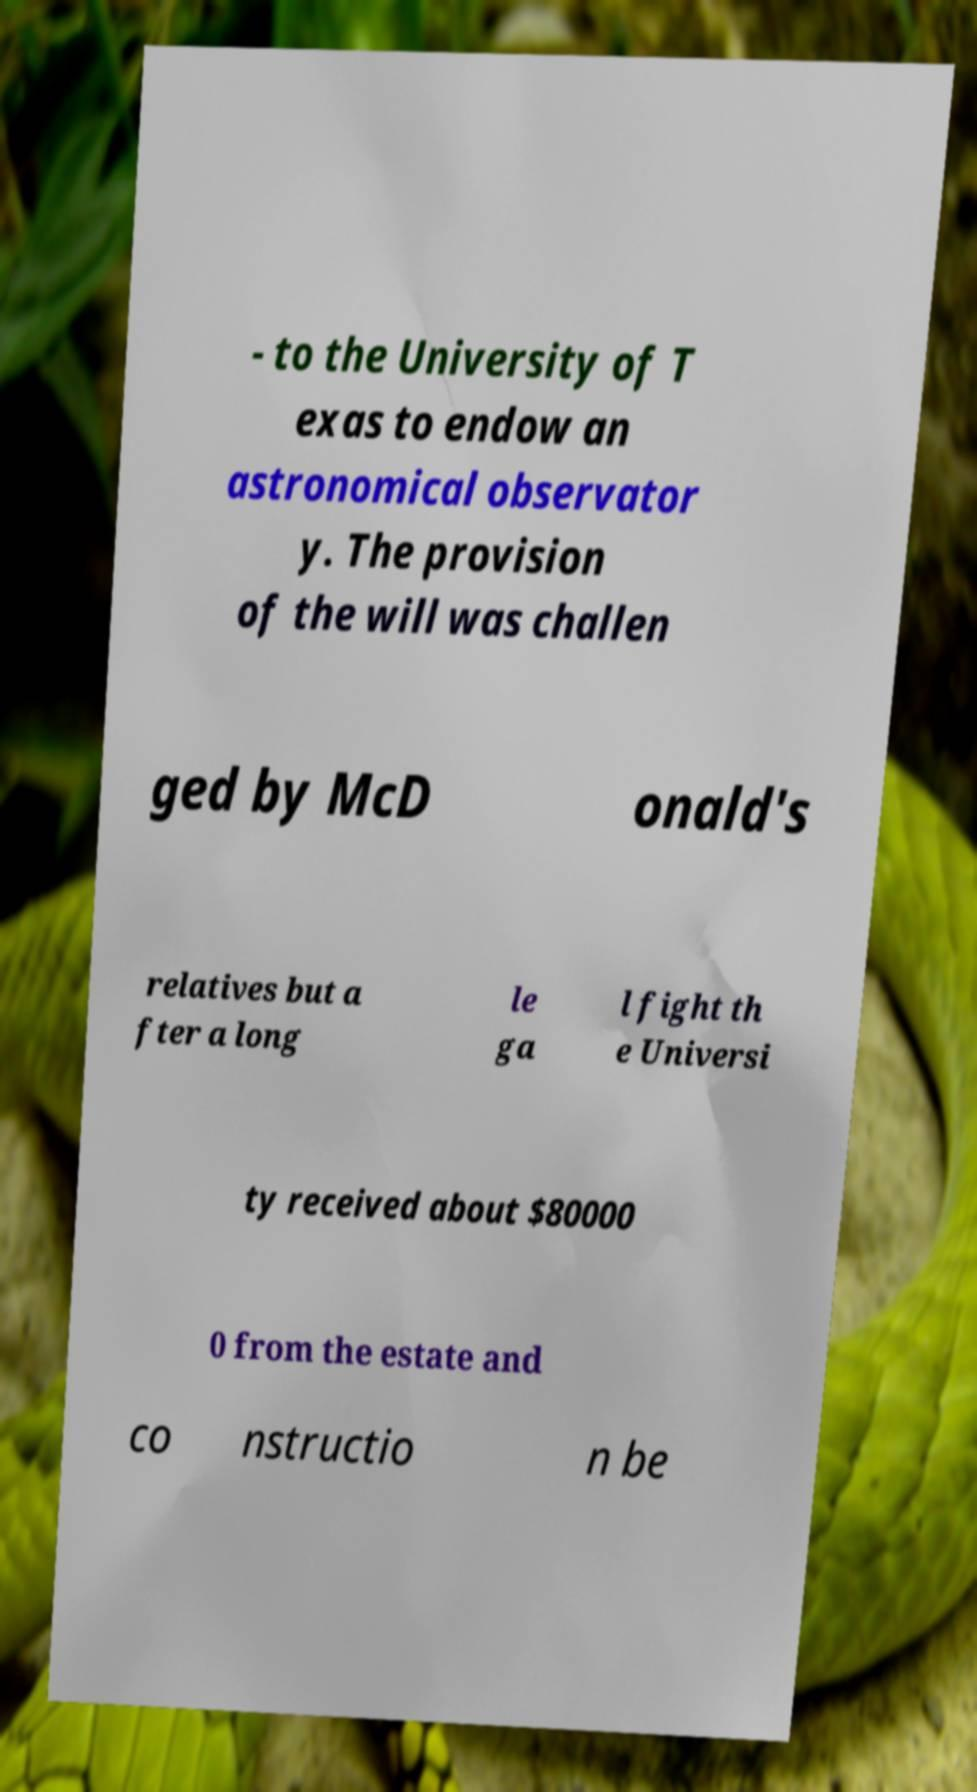Please read and relay the text visible in this image. What does it say? - to the University of T exas to endow an astronomical observator y. The provision of the will was challen ged by McD onald's relatives but a fter a long le ga l fight th e Universi ty received about $80000 0 from the estate and co nstructio n be 